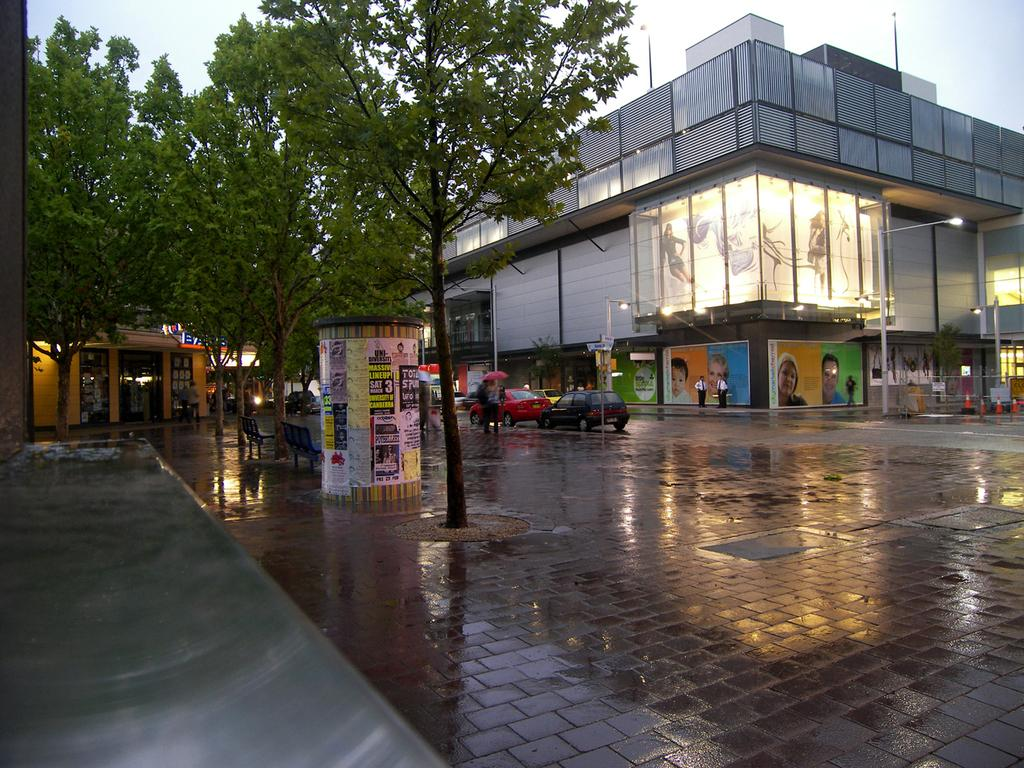What type of vegetation can be seen in the image? There are trees in the image. What type of seating is available in the image? There are benches in the image. What type of pathway is present in the image? There is a road in the image. What can be seen in the background of the image? In the background, there is a car, lights on poles, buildings, and the sky. What advice is being given on the chalkboard in the image? There is no chalkboard present in the image, so no advice can be given. 